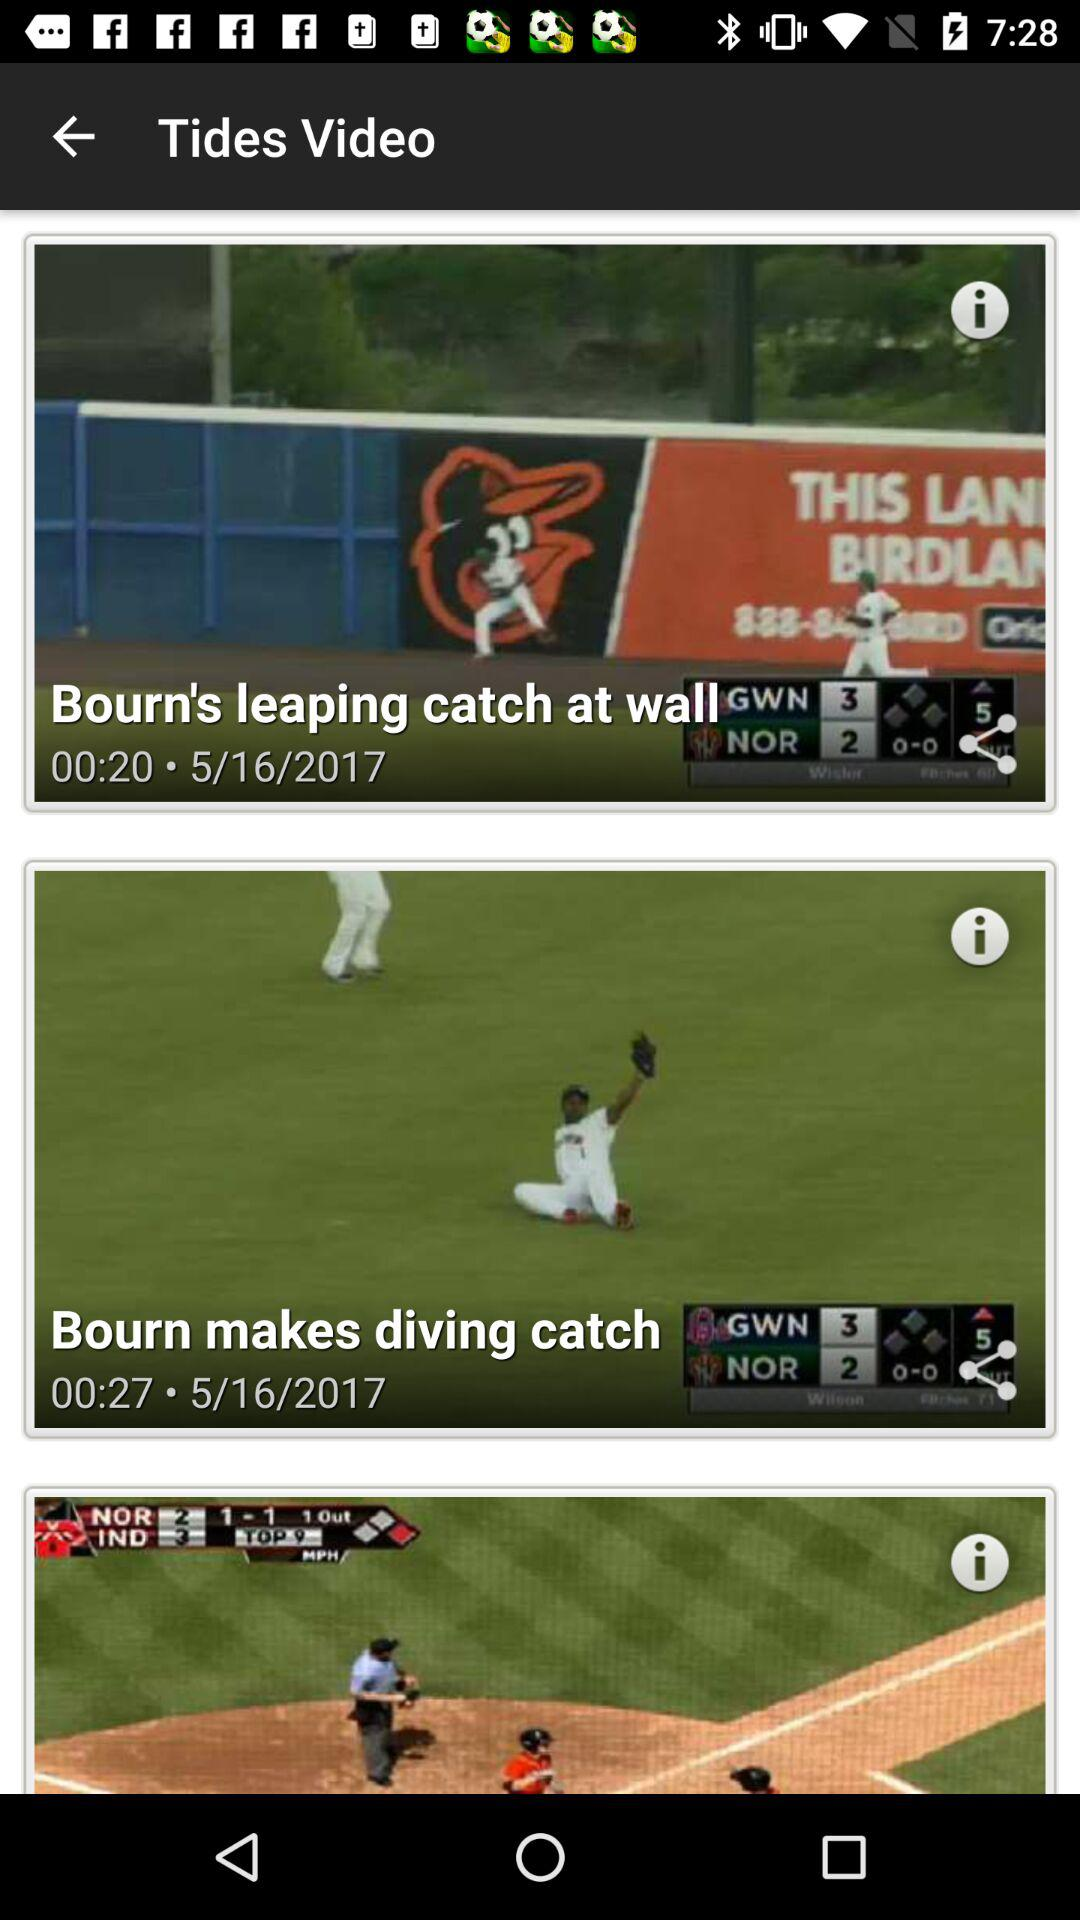What is the duration of "Bourn makes diving catch"? The duration is 00:27. 